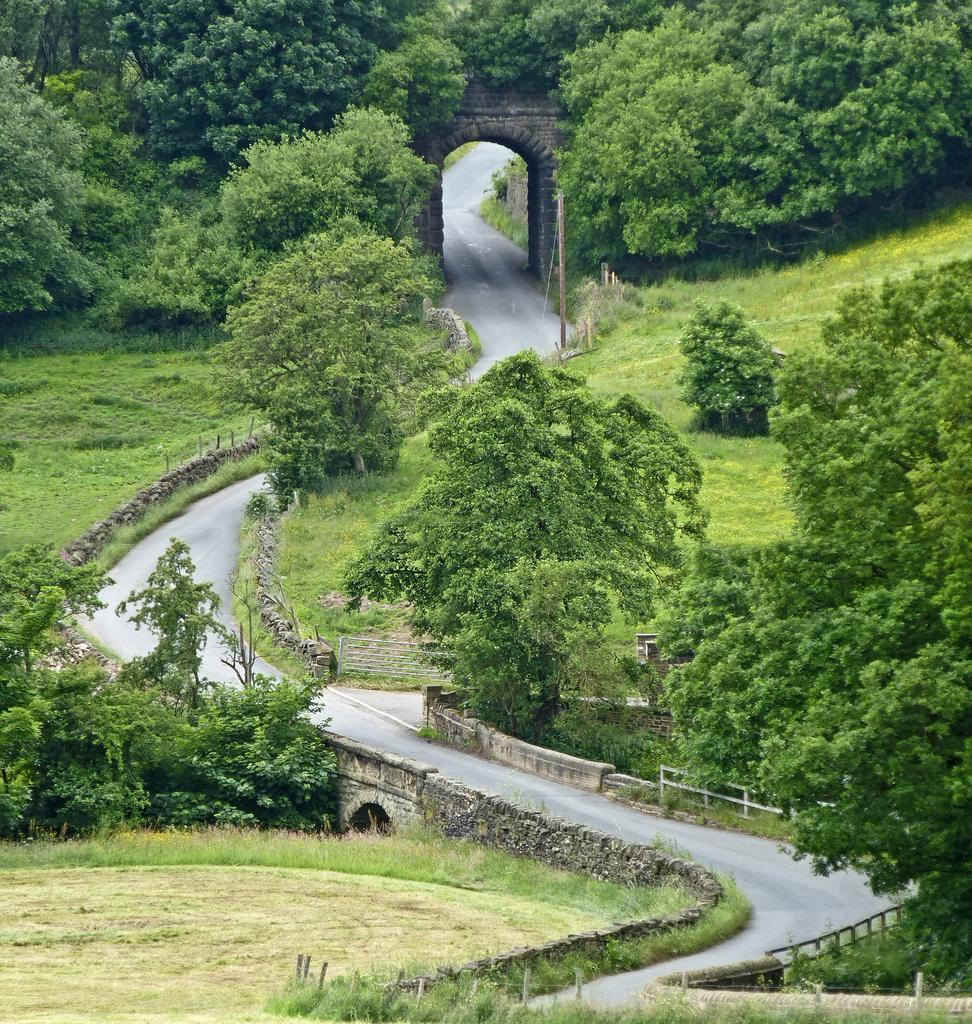What is the main feature of the image? There is a road in the image. What can be seen beside the road? There is grass, plants, and trees beside the road. What grade is the moon in the image? There is no moon present in the image. How fast are the runners going in the image? There are no runners present in the image. 